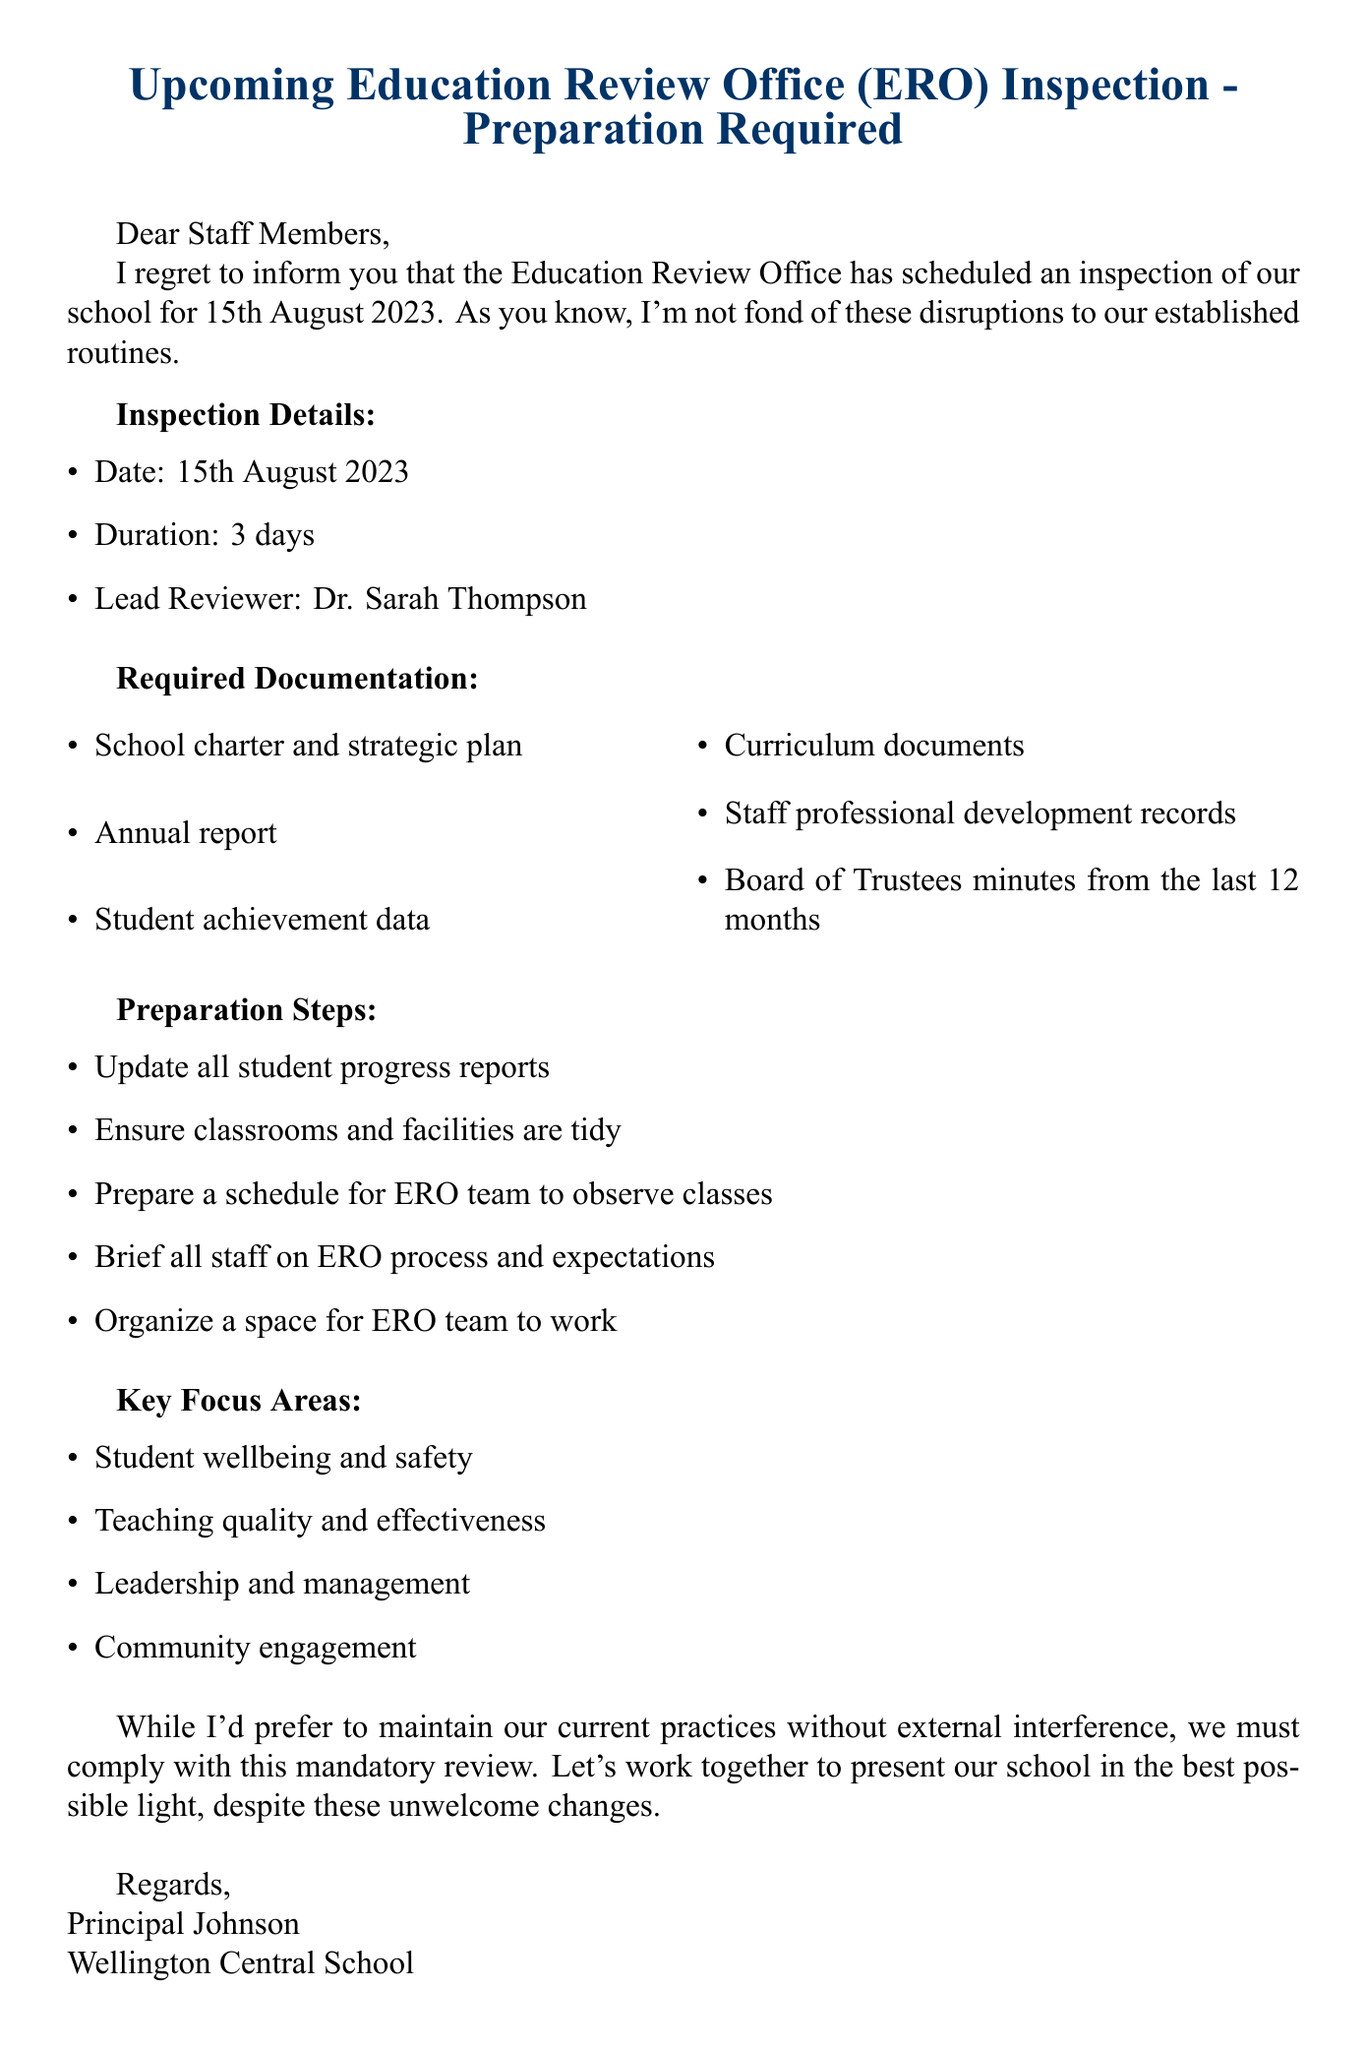What is the date of the inspection? The date of the inspection is explicitly stated in the document.
Answer: 15th August 2023 Who is the lead reviewer for the inspection? The document mentions the name of the lead reviewer responsible for the inspection.
Answer: Dr. Sarah Thompson How many days will the inspection last? The duration of the inspection is clearly defined in the document.
Answer: 3 days What is one of the required documents? The document lists several required documents; one can be extracted from that list.
Answer: School charter and strategic plan What should be updated before the inspection? The preparation steps detail actions that need to be taken before the inspection, including updates.
Answer: All student progress reports Which area focuses on teaching quality? The key focus areas include various topics, one of which directly relates to teaching quality.
Answer: Teaching quality and effectiveness What type of document is this? The structure and presentation indicate the nature of the communication.
Answer: Mail What should be organized for the ERO team? The document specifies certain arrangements that need to be made for the ERO team.
Answer: A space for ERO team to work 